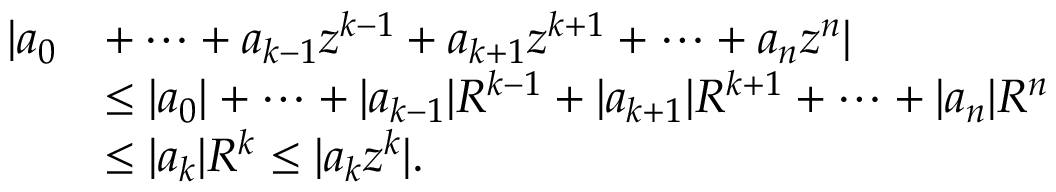<formula> <loc_0><loc_0><loc_500><loc_500>{ \begin{array} { r l } { | a _ { 0 } } & { + \cdots + a _ { k - 1 } z ^ { k - 1 } + a _ { k + 1 } z ^ { k + 1 } + \cdots + a _ { n } z ^ { n } | } \\ & { \leq | a _ { 0 } | + \cdots + | a _ { k - 1 } | R ^ { k - 1 } + | a _ { k + 1 } | R ^ { k + 1 } + \cdots + | a _ { n } | R ^ { n } } \\ & { \leq | a _ { k } | R ^ { k } \leq | a _ { k } z ^ { k } | . } \end{array} }</formula> 